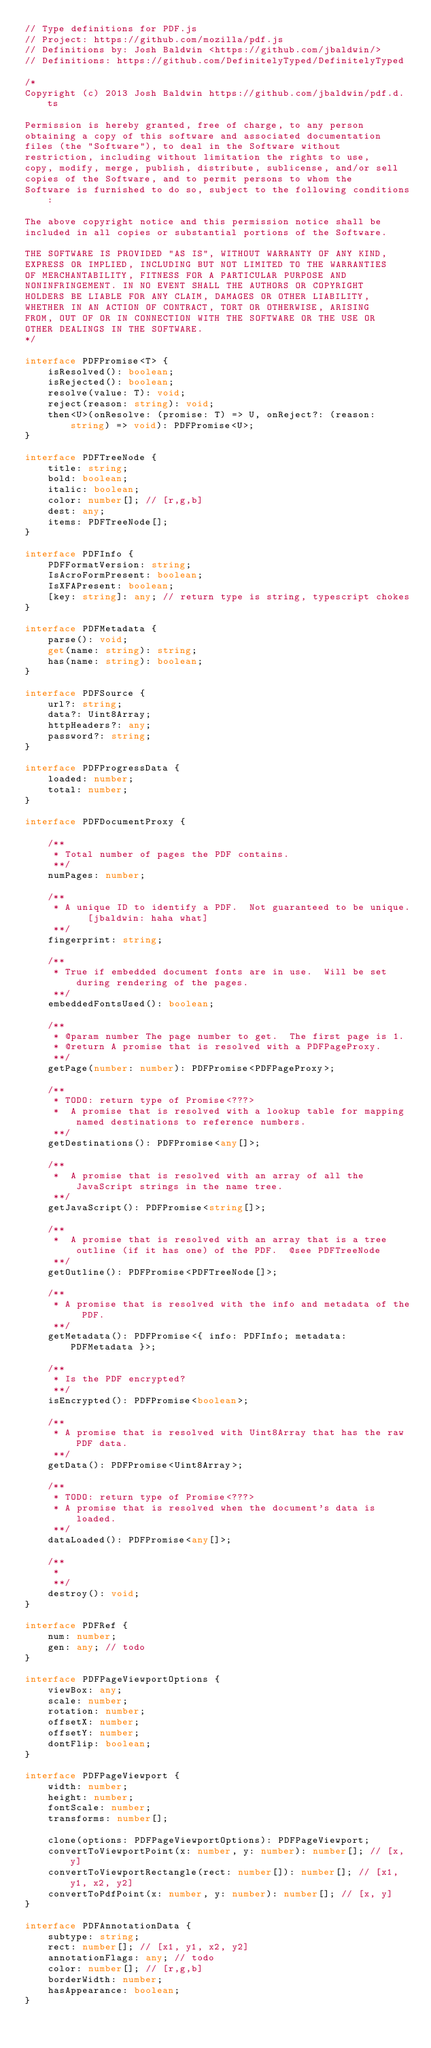Convert code to text. <code><loc_0><loc_0><loc_500><loc_500><_TypeScript_>// Type definitions for PDF.js
// Project: https://github.com/mozilla/pdf.js
// Definitions by: Josh Baldwin <https://github.com/jbaldwin/>
// Definitions: https://github.com/DefinitelyTyped/DefinitelyTyped

/*
Copyright (c) 2013 Josh Baldwin https://github.com/jbaldwin/pdf.d.ts

Permission is hereby granted, free of charge, to any person
obtaining a copy of this software and associated documentation
files (the "Software"), to deal in the Software without
restriction, including without limitation the rights to use,
copy, modify, merge, publish, distribute, sublicense, and/or sell
copies of the Software, and to permit persons to whom the
Software is furnished to do so, subject to the following conditions:

The above copyright notice and this permission notice shall be
included in all copies or substantial portions of the Software.

THE SOFTWARE IS PROVIDED "AS IS", WITHOUT WARRANTY OF ANY KIND,
EXPRESS OR IMPLIED, INCLUDING BUT NOT LIMITED TO THE WARRANTIES
OF MERCHANTABILITY, FITNESS FOR A PARTICULAR PURPOSE AND
NONINFRINGEMENT. IN NO EVENT SHALL THE AUTHORS OR COPYRIGHT
HOLDERS BE LIABLE FOR ANY CLAIM, DAMAGES OR OTHER LIABILITY,
WHETHER IN AN ACTION OF CONTRACT, TORT OR OTHERWISE, ARISING
FROM, OUT OF OR IN CONNECTION WITH THE SOFTWARE OR THE USE OR
OTHER DEALINGS IN THE SOFTWARE.
*/

interface PDFPromise<T> {
	isResolved(): boolean;
	isRejected(): boolean;
	resolve(value: T): void;
	reject(reason: string): void;
	then<U>(onResolve: (promise: T) => U, onReject?: (reason: string) => void): PDFPromise<U>;
}

interface PDFTreeNode {
	title: string;
	bold: boolean;
	italic: boolean;
	color: number[]; // [r,g,b]
	dest: any;
	items: PDFTreeNode[];
}

interface PDFInfo {
	PDFFormatVersion: string;
	IsAcroFormPresent: boolean;
	IsXFAPresent: boolean;
	[key: string]: any;	// return type is string, typescript chokes
}

interface PDFMetadata {
	parse(): void;
	get(name: string): string;
	has(name: string): boolean;
}

interface PDFSource {
	url?: string;
	data?: Uint8Array;
	httpHeaders?: any;
	password?: string;
}

interface PDFProgressData {
	loaded: number;
	total: number;
}

interface PDFDocumentProxy {

	/**
	 * Total number of pages the PDF contains.
	 **/
	numPages: number;

	/**
	 * A unique ID to identify a PDF.  Not guaranteed to be unique.  [jbaldwin: haha what]
	 **/
	fingerprint: string;

	/**
	 * True if embedded document fonts are in use.  Will be set during rendering of the pages.
	 **/
	embeddedFontsUsed(): boolean;

	/**
	 * @param number The page number to get.  The first page is 1.
	 * @return A promise that is resolved with a PDFPageProxy.
	 **/
	getPage(number: number): PDFPromise<PDFPageProxy>;

	/**
	 * TODO: return type of Promise<???>
	 *  A promise that is resolved with a lookup table for mapping named destinations to reference numbers.
	 **/
	getDestinations(): PDFPromise<any[]>;

	/**
	 *  A promise that is resolved with an array of all the JavaScript strings in the name tree.
	 **/
	getJavaScript(): PDFPromise<string[]>;

	/**
	 *  A promise that is resolved with an array that is a tree outline (if it has one) of the PDF.  @see PDFTreeNode
	 **/
	getOutline(): PDFPromise<PDFTreeNode[]>;

	/**
	 * A promise that is resolved with the info and metadata of the PDF.
	 **/
	getMetadata(): PDFPromise<{ info: PDFInfo; metadata: PDFMetadata }>;

	/**
	 * Is the PDF encrypted?
	 **/
	isEncrypted(): PDFPromise<boolean>;

	/**
	 * A promise that is resolved with Uint8Array that has the raw PDF data.
	 **/
	getData(): PDFPromise<Uint8Array>;

	/**
	 * TODO: return type of Promise<???>
	 * A promise that is resolved when the document's data is loaded.
	 **/
	dataLoaded(): PDFPromise<any[]>;

	/**
	 *
	 **/
	destroy(): void;
}

interface PDFRef {
	num: number;
	gen: any; // todo
}

interface PDFPageViewportOptions {
	viewBox: any;
	scale: number;
	rotation: number;
	offsetX: number;
	offsetY: number;
	dontFlip: boolean;
}

interface PDFPageViewport {
	width: number;
	height: number;
	fontScale: number;
	transforms: number[];

	clone(options: PDFPageViewportOptions): PDFPageViewport;
	convertToViewportPoint(x: number, y: number): number[]; // [x, y]
	convertToViewportRectangle(rect: number[]): number[]; // [x1, y1, x2, y2]
	convertToPdfPoint(x: number, y: number): number[]; // [x, y]
}

interface PDFAnnotationData {
	subtype: string;
	rect: number[]; // [x1, y1, x2, y2]
	annotationFlags: any; // todo
	color: number[]; // [r,g,b]
	borderWidth: number;
	hasAppearance: boolean;
}
</code> 